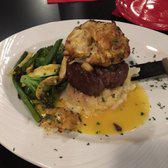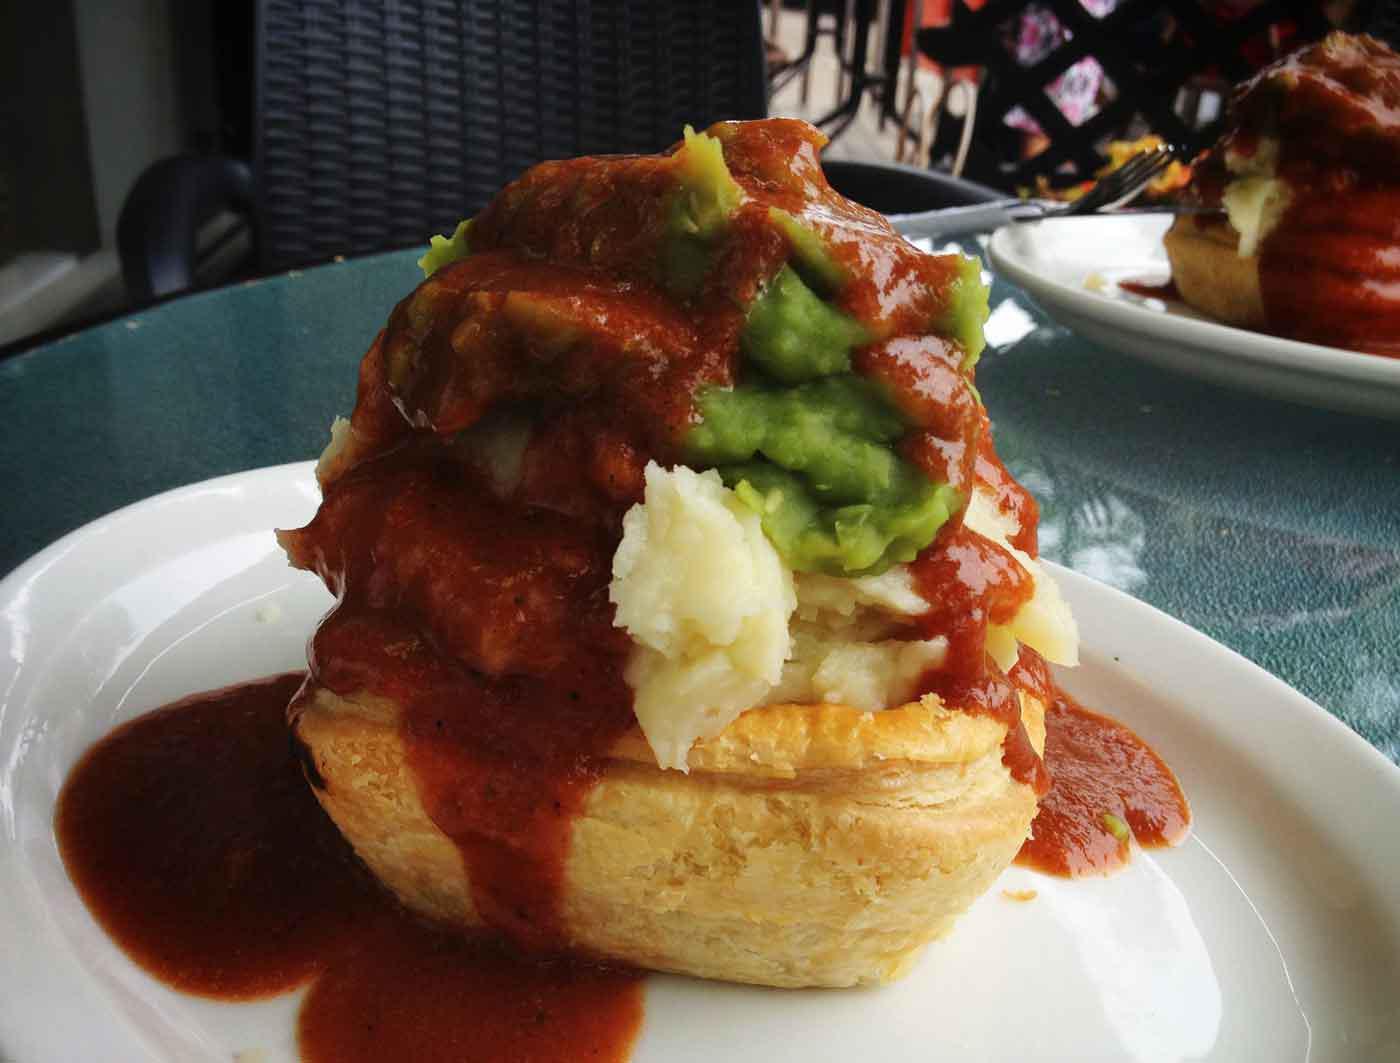The first image is the image on the left, the second image is the image on the right. For the images shown, is this caption "A serving of cooked green vegetables is on a plate next to some type of prepared meat." true? Answer yes or no. Yes. The first image is the image on the left, the second image is the image on the right. Evaluate the accuracy of this statement regarding the images: "The right dish is entirely layered, the left dish has a green vegetable.". Is it true? Answer yes or no. Yes. 